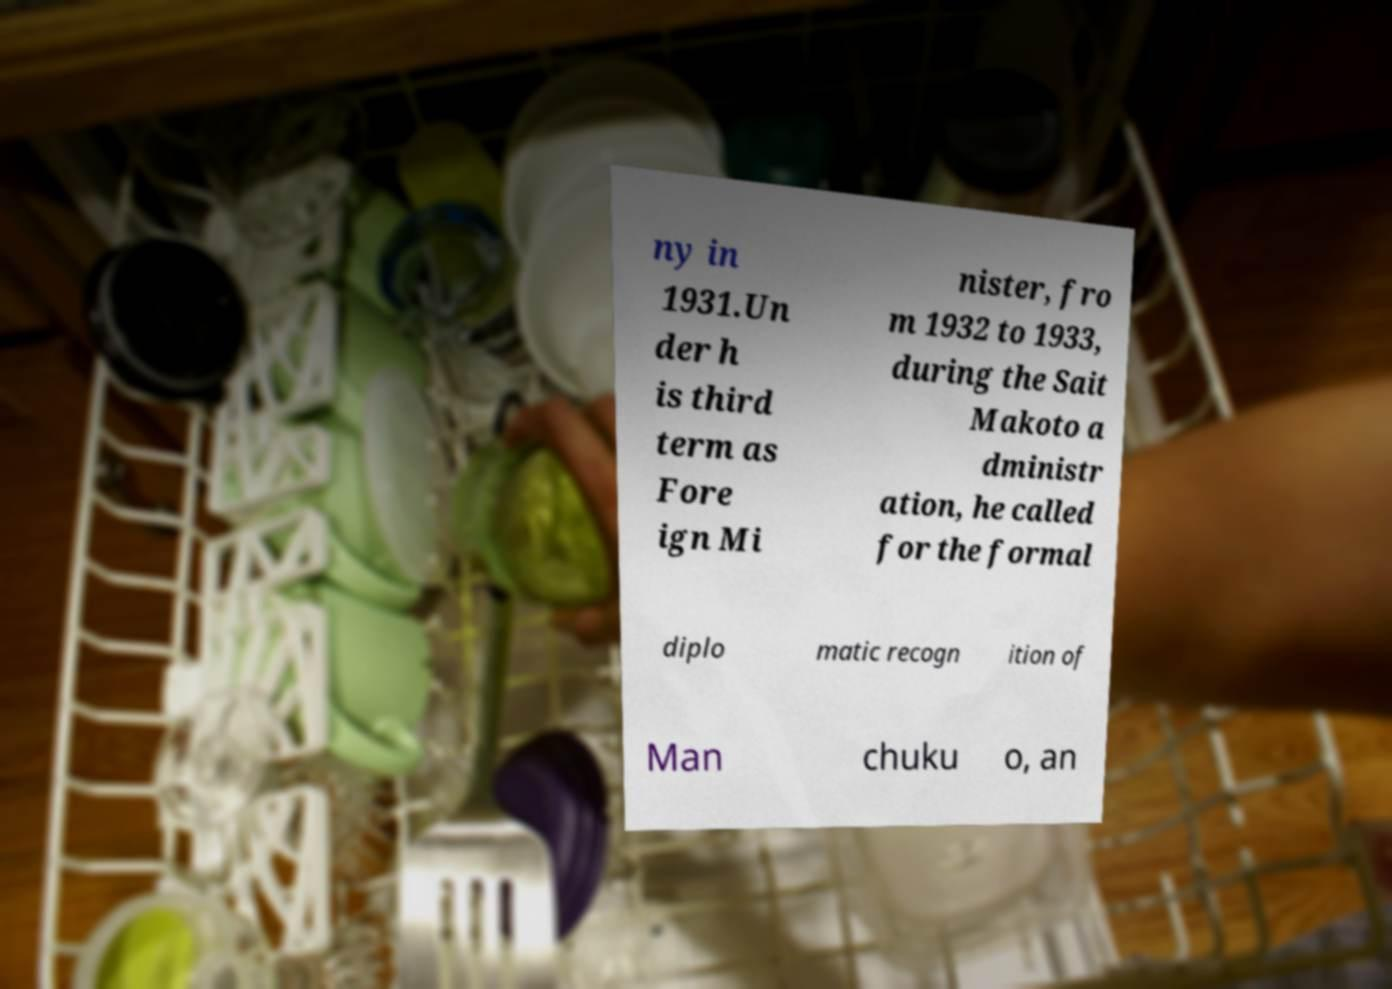Please read and relay the text visible in this image. What does it say? ny in 1931.Un der h is third term as Fore ign Mi nister, fro m 1932 to 1933, during the Sait Makoto a dministr ation, he called for the formal diplo matic recogn ition of Man chuku o, an 